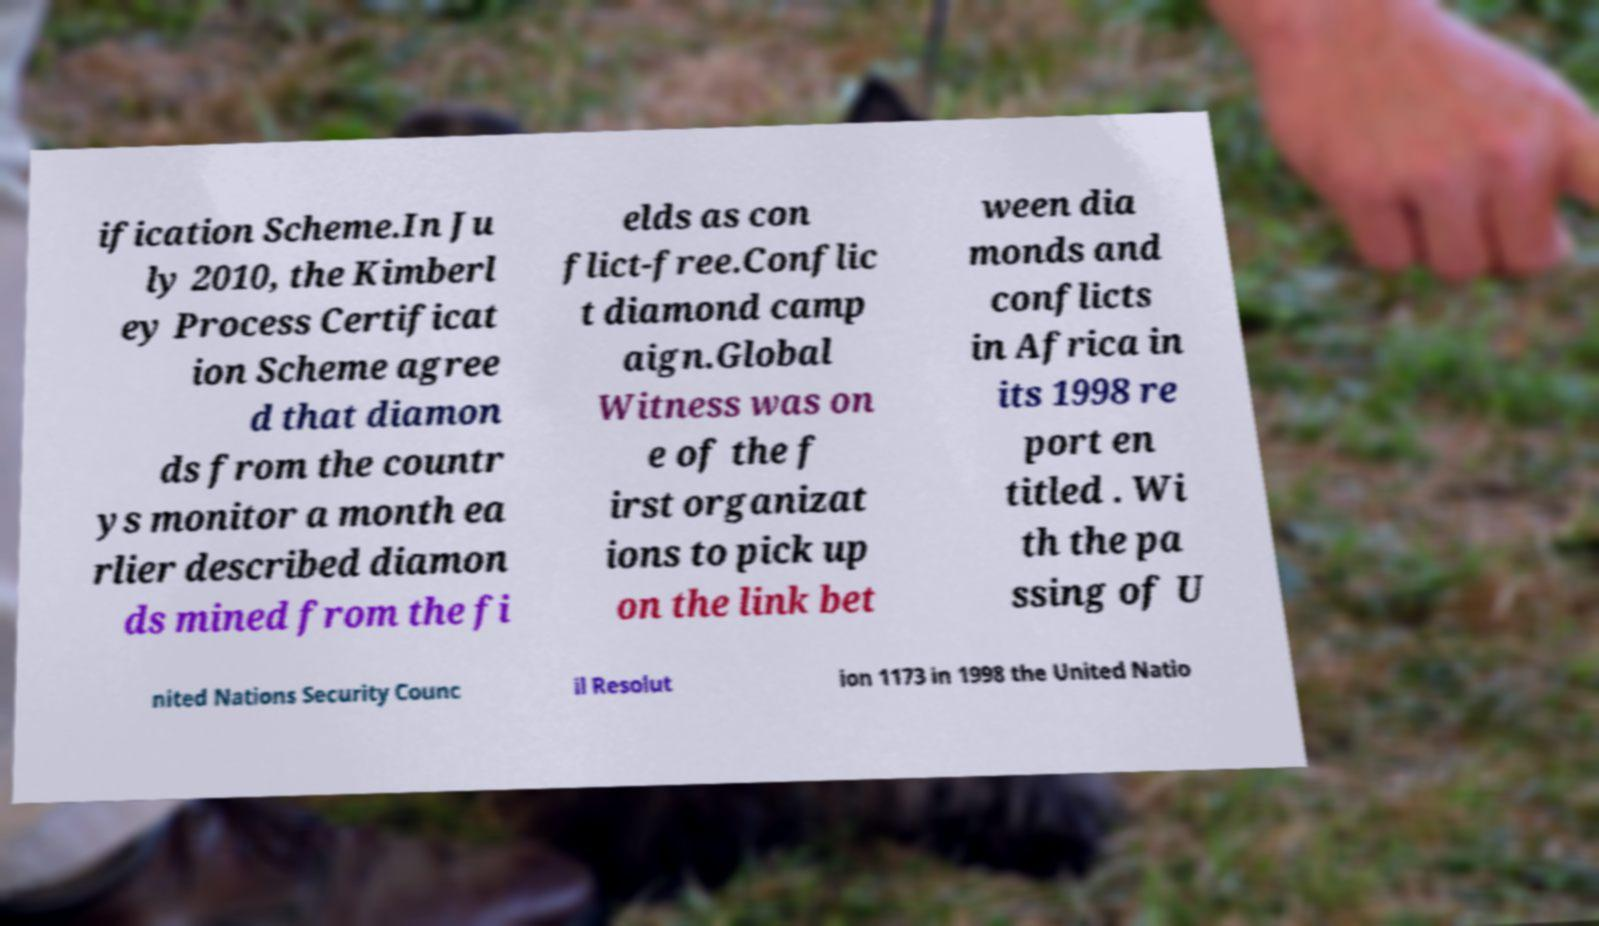Could you extract and type out the text from this image? ification Scheme.In Ju ly 2010, the Kimberl ey Process Certificat ion Scheme agree d that diamon ds from the countr ys monitor a month ea rlier described diamon ds mined from the fi elds as con flict-free.Conflic t diamond camp aign.Global Witness was on e of the f irst organizat ions to pick up on the link bet ween dia monds and conflicts in Africa in its 1998 re port en titled . Wi th the pa ssing of U nited Nations Security Counc il Resolut ion 1173 in 1998 the United Natio 